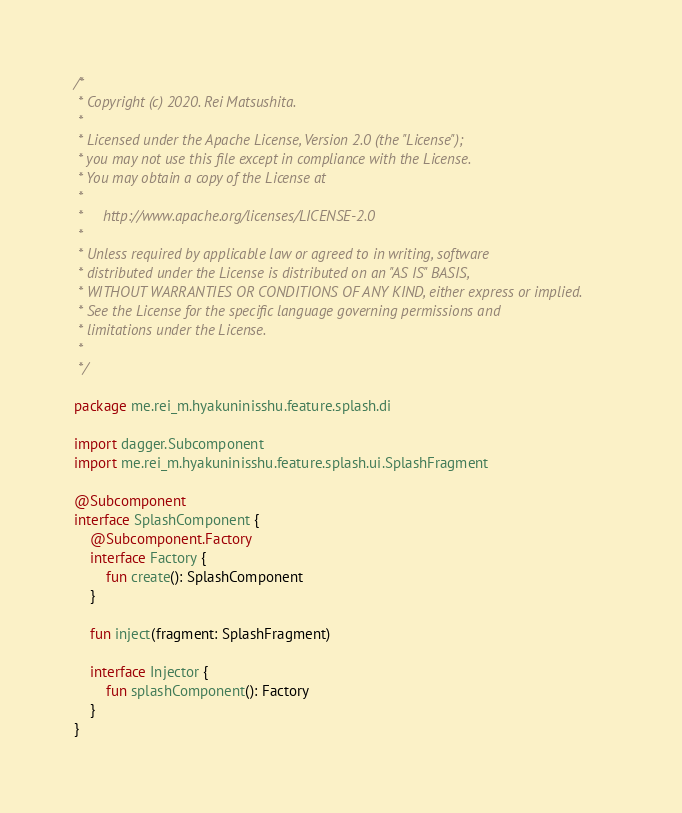<code> <loc_0><loc_0><loc_500><loc_500><_Kotlin_>/*
 * Copyright (c) 2020. Rei Matsushita.
 *
 * Licensed under the Apache License, Version 2.0 (the "License");
 * you may not use this file except in compliance with the License.
 * You may obtain a copy of the License at
 *
 *     http://www.apache.org/licenses/LICENSE-2.0
 *
 * Unless required by applicable law or agreed to in writing, software
 * distributed under the License is distributed on an "AS IS" BASIS,
 * WITHOUT WARRANTIES OR CONDITIONS OF ANY KIND, either express or implied.
 * See the License for the specific language governing permissions and
 * limitations under the License.
 *
 */

package me.rei_m.hyakuninisshu.feature.splash.di

import dagger.Subcomponent
import me.rei_m.hyakuninisshu.feature.splash.ui.SplashFragment

@Subcomponent
interface SplashComponent {
    @Subcomponent.Factory
    interface Factory {
        fun create(): SplashComponent
    }

    fun inject(fragment: SplashFragment)

    interface Injector {
        fun splashComponent(): Factory
    }
}
</code> 